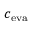<formula> <loc_0><loc_0><loc_500><loc_500>c _ { e v a }</formula> 